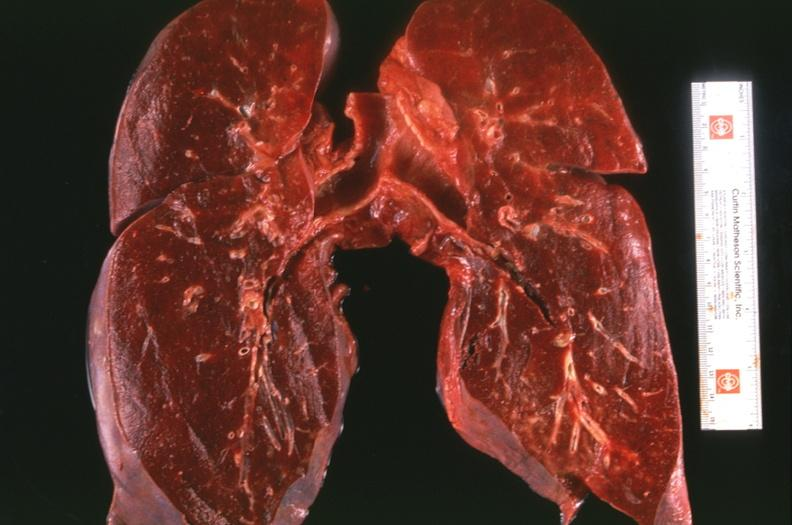does leukoplakia vocal cord show lung, congestion, heart failure cells hemosiderin laden macrophages?
Answer the question using a single word or phrase. No 